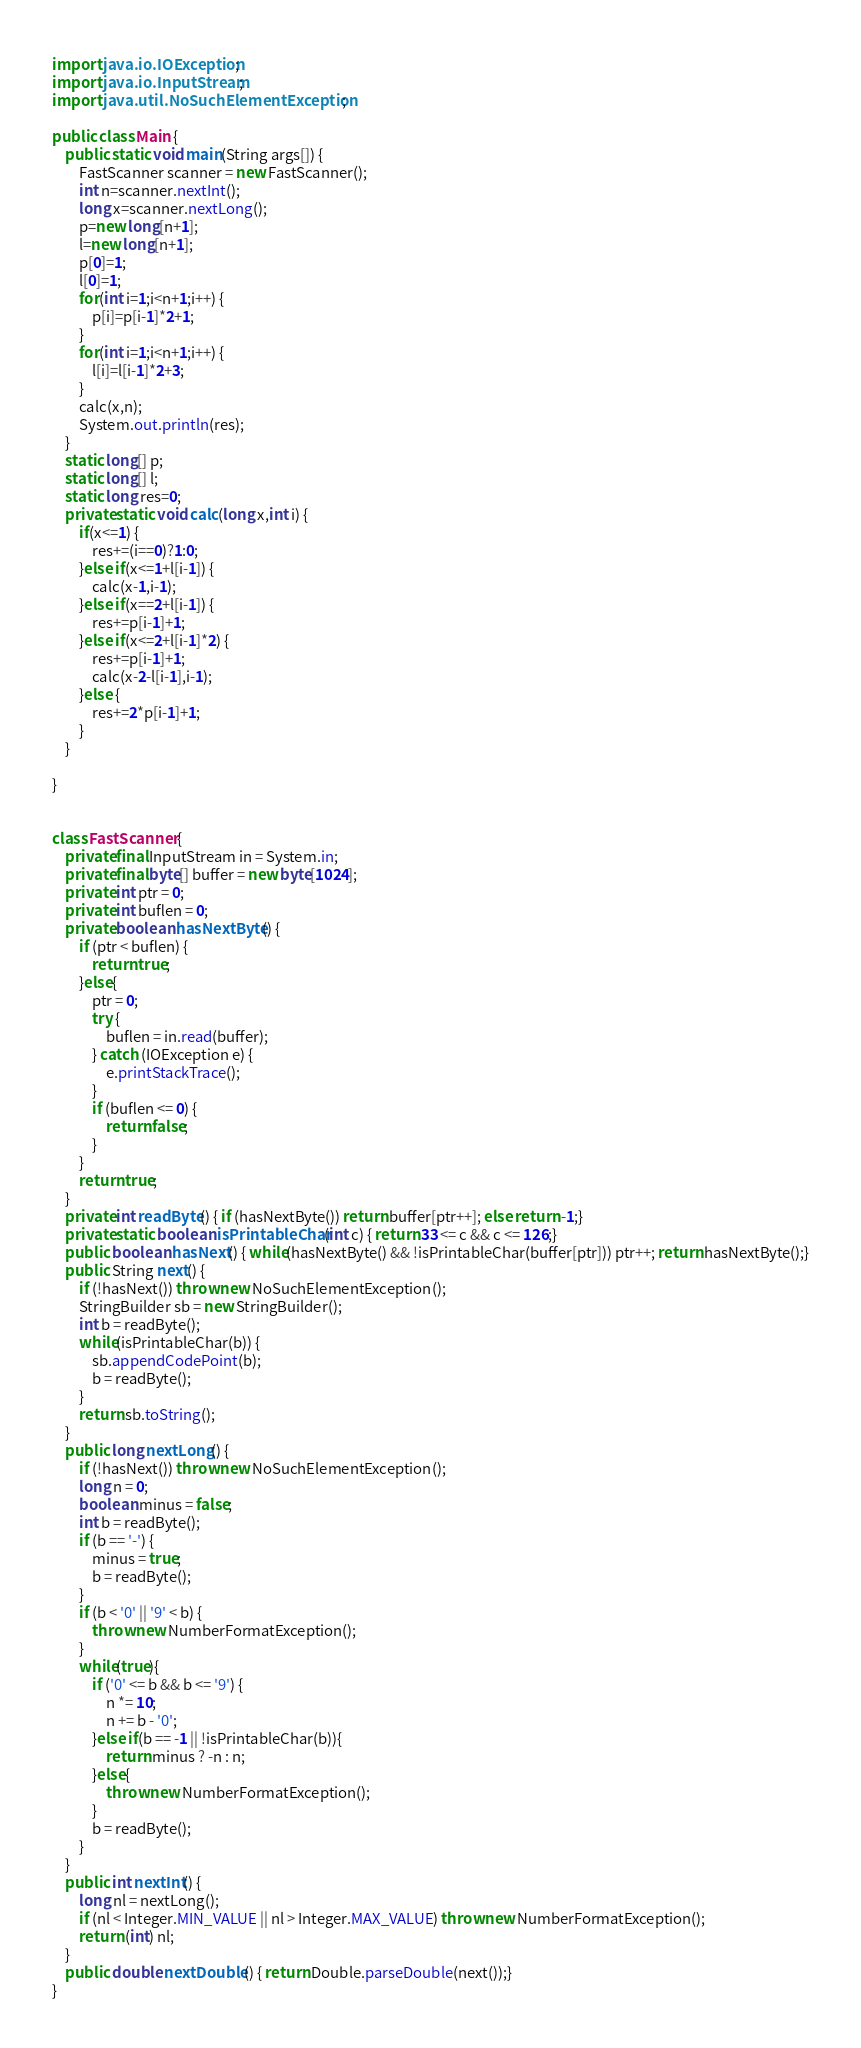Convert code to text. <code><loc_0><loc_0><loc_500><loc_500><_Java_>import java.io.IOException;
import java.io.InputStream;
import java.util.NoSuchElementException;

public class Main {
	public static void main(String args[]) {
		FastScanner scanner = new FastScanner();
		int n=scanner.nextInt();
		long x=scanner.nextLong();
		p=new long[n+1];
		l=new long[n+1];
		p[0]=1;
		l[0]=1;
		for(int i=1;i<n+1;i++) {
			p[i]=p[i-1]*2+1;
		}
		for(int i=1;i<n+1;i++) {
			l[i]=l[i-1]*2+3;
		}
		calc(x,n);
		System.out.println(res);
	}
	static long[] p;
	static long[] l;
	static long res=0;
	private static void calc(long x,int i) {
		if(x<=1) {
			res+=(i==0)?1:0;
		}else if(x<=1+l[i-1]) {
			calc(x-1,i-1);
		}else if(x==2+l[i-1]) {
			res+=p[i-1]+1;
		}else if(x<=2+l[i-1]*2) {
			res+=p[i-1]+1;
			calc(x-2-l[i-1],i-1);
		}else {
			res+=2*p[i-1]+1;
		}
	}
	
}


class FastScanner {
    private final InputStream in = System.in;
    private final byte[] buffer = new byte[1024];
    private int ptr = 0;
    private int buflen = 0;
    private boolean hasNextByte() {
        if (ptr < buflen) {
            return true;
        }else{
            ptr = 0;
            try {
                buflen = in.read(buffer);
            } catch (IOException e) {
                e.printStackTrace();
            }
            if (buflen <= 0) {
                return false;
            }
        }
        return true;
    }
    private int readByte() { if (hasNextByte()) return buffer[ptr++]; else return -1;}
    private static boolean isPrintableChar(int c) { return 33 <= c && c <= 126;}
    public boolean hasNext() { while(hasNextByte() && !isPrintableChar(buffer[ptr])) ptr++; return hasNextByte();}
    public String next() {
        if (!hasNext()) throw new NoSuchElementException();
        StringBuilder sb = new StringBuilder();
        int b = readByte();
        while(isPrintableChar(b)) {
            sb.appendCodePoint(b);
            b = readByte();
        }
        return sb.toString();
    }
    public long nextLong() {
        if (!hasNext()) throw new NoSuchElementException();
        long n = 0;
        boolean minus = false;
        int b = readByte();
        if (b == '-') {
            minus = true;
            b = readByte();
        }
        if (b < '0' || '9' < b) {
            throw new NumberFormatException();
        }
        while(true){
            if ('0' <= b && b <= '9') {
                n *= 10;
                n += b - '0';
            }else if(b == -1 || !isPrintableChar(b)){
                return minus ? -n : n;
            }else{
                throw new NumberFormatException();
            }
            b = readByte();
        }
    }
    public int nextInt() {
        long nl = nextLong();
        if (nl < Integer.MIN_VALUE || nl > Integer.MAX_VALUE) throw new NumberFormatException();
        return (int) nl;
    }
    public double nextDouble() { return Double.parseDouble(next());}
}
</code> 